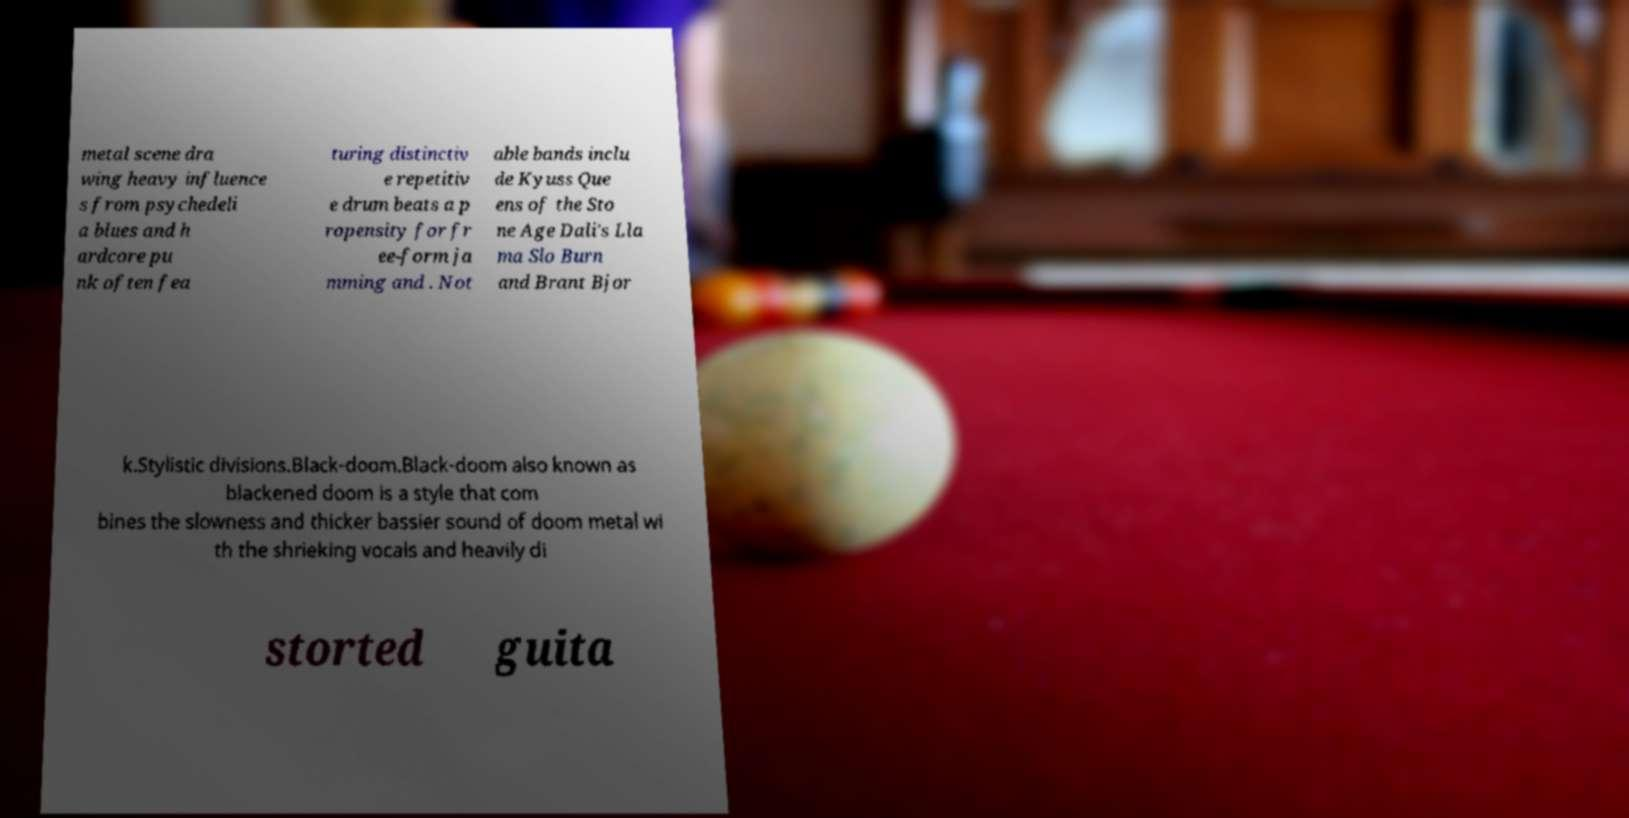Please read and relay the text visible in this image. What does it say? metal scene dra wing heavy influence s from psychedeli a blues and h ardcore pu nk often fea turing distinctiv e repetitiv e drum beats a p ropensity for fr ee-form ja mming and . Not able bands inclu de Kyuss Que ens of the Sto ne Age Dali's Lla ma Slo Burn and Brant Bjor k.Stylistic divisions.Black-doom.Black-doom also known as blackened doom is a style that com bines the slowness and thicker bassier sound of doom metal wi th the shrieking vocals and heavily di storted guita 